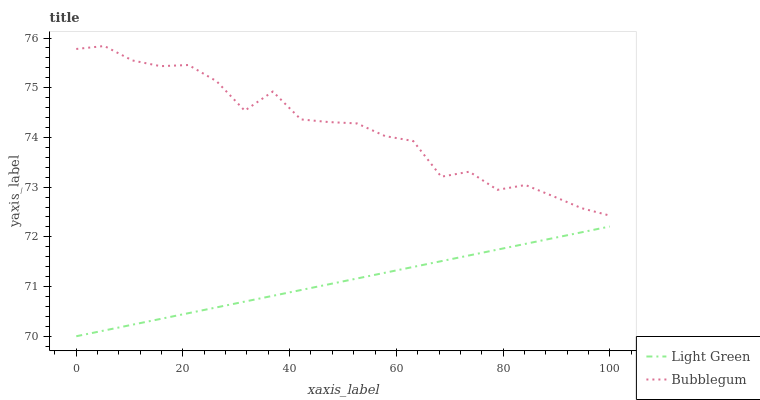Does Light Green have the maximum area under the curve?
Answer yes or no. No. Is Light Green the roughest?
Answer yes or no. No. Does Light Green have the highest value?
Answer yes or no. No. Is Light Green less than Bubblegum?
Answer yes or no. Yes. Is Bubblegum greater than Light Green?
Answer yes or no. Yes. Does Light Green intersect Bubblegum?
Answer yes or no. No. 